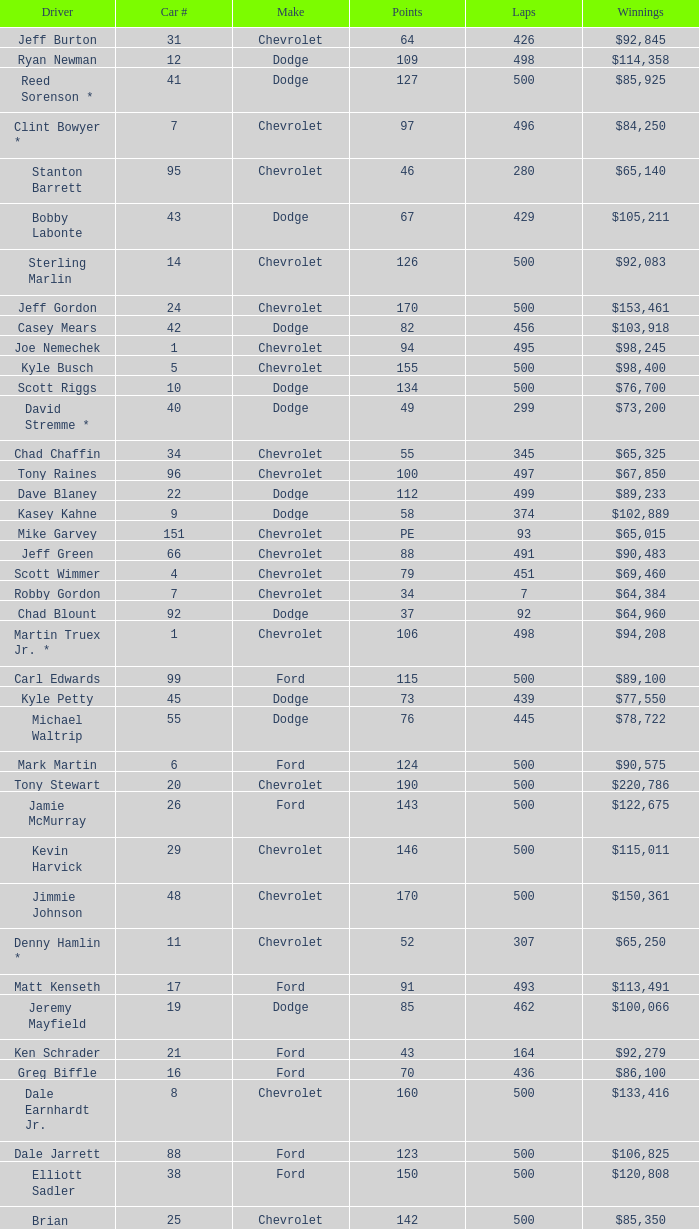Could you help me parse every detail presented in this table? {'header': ['Driver', 'Car #', 'Make', 'Points', 'Laps', 'Winnings'], 'rows': [['Jeff Burton', '31', 'Chevrolet', '64', '426', '$92,845'], ['Ryan Newman', '12', 'Dodge', '109', '498', '$114,358'], ['Reed Sorenson *', '41', 'Dodge', '127', '500', '$85,925'], ['Clint Bowyer *', '7', 'Chevrolet', '97', '496', '$84,250'], ['Stanton Barrett', '95', 'Chevrolet', '46', '280', '$65,140'], ['Bobby Labonte', '43', 'Dodge', '67', '429', '$105,211'], ['Sterling Marlin', '14', 'Chevrolet', '126', '500', '$92,083'], ['Jeff Gordon', '24', 'Chevrolet', '170', '500', '$153,461'], ['Casey Mears', '42', 'Dodge', '82', '456', '$103,918'], ['Joe Nemechek', '1', 'Chevrolet', '94', '495', '$98,245'], ['Kyle Busch', '5', 'Chevrolet', '155', '500', '$98,400'], ['Scott Riggs', '10', 'Dodge', '134', '500', '$76,700'], ['David Stremme *', '40', 'Dodge', '49', '299', '$73,200'], ['Chad Chaffin', '34', 'Chevrolet', '55', '345', '$65,325'], ['Tony Raines', '96', 'Chevrolet', '100', '497', '$67,850'], ['Dave Blaney', '22', 'Dodge', '112', '499', '$89,233'], ['Kasey Kahne', '9', 'Dodge', '58', '374', '$102,889'], ['Mike Garvey', '151', 'Chevrolet', 'PE', '93', '$65,015'], ['Jeff Green', '66', 'Chevrolet', '88', '491', '$90,483'], ['Scott Wimmer', '4', 'Chevrolet', '79', '451', '$69,460'], ['Robby Gordon', '7', 'Chevrolet', '34', '7', '$64,384'], ['Chad Blount', '92', 'Dodge', '37', '92', '$64,960'], ['Martin Truex Jr. *', '1', 'Chevrolet', '106', '498', '$94,208'], ['Carl Edwards', '99', 'Ford', '115', '500', '$89,100'], ['Kyle Petty', '45', 'Dodge', '73', '439', '$77,550'], ['Michael Waltrip', '55', 'Dodge', '76', '445', '$78,722'], ['Mark Martin', '6', 'Ford', '124', '500', '$90,575'], ['Tony Stewart', '20', 'Chevrolet', '190', '500', '$220,786'], ['Jamie McMurray', '26', 'Ford', '143', '500', '$122,675'], ['Kevin Harvick', '29', 'Chevrolet', '146', '500', '$115,011'], ['Jimmie Johnson', '48', 'Chevrolet', '170', '500', '$150,361'], ['Denny Hamlin *', '11', 'Chevrolet', '52', '307', '$65,250'], ['Matt Kenseth', '17', 'Ford', '91', '493', '$113,491'], ['Jeremy Mayfield', '19', 'Dodge', '85', '462', '$100,066'], ['Ken Schrader', '21', 'Ford', '43', '164', '$92,279'], ['Greg Biffle', '16', 'Ford', '70', '436', '$86,100'], ['Dale Earnhardt Jr.', '8', 'Chevrolet', '160', '500', '$133,416'], ['Dale Jarrett', '88', 'Ford', '123', '500', '$106,825'], ['Elliott Sadler', '38', 'Ford', '150', '500', '$120,808'], ['Brian Vickers', '25', 'Chevrolet', '142', '500', '$85,350'], ['Kurt Busch', '2', 'Dodge', '130', '500', '$111,683'], ['Travis Kvapil', '32', 'Chevrolet', '61', '403', '$65,425'], ['J.J. Yeley *', '18', 'Chevrolet', '108', '497', '$109,125']]} What make of car did Brian Vickers drive? Chevrolet. 